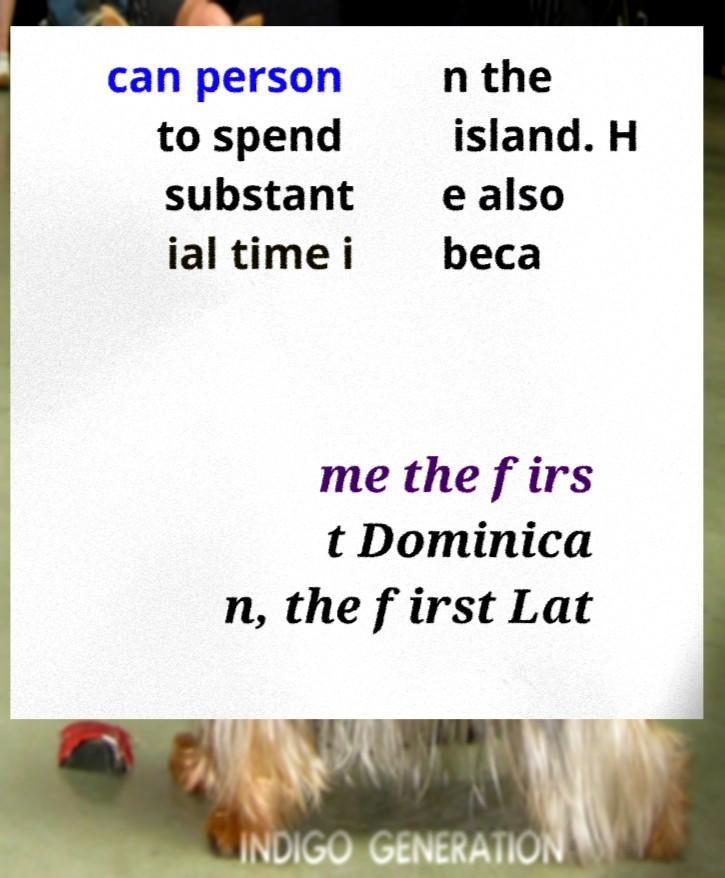Could you extract and type out the text from this image? can person to spend substant ial time i n the island. H e also beca me the firs t Dominica n, the first Lat 